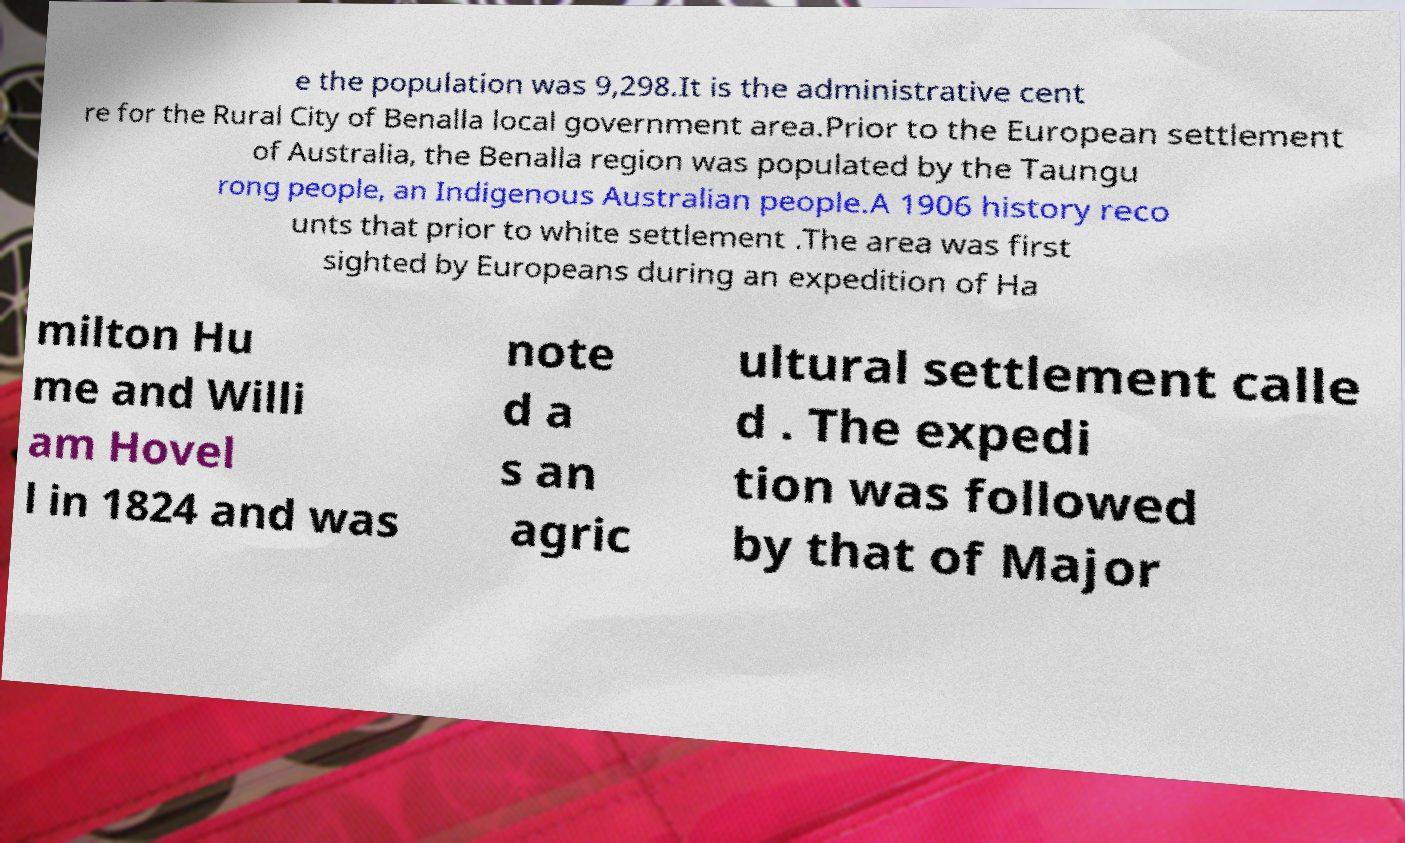Can you accurately transcribe the text from the provided image for me? e the population was 9,298.It is the administrative cent re for the Rural City of Benalla local government area.Prior to the European settlement of Australia, the Benalla region was populated by the Taungu rong people, an Indigenous Australian people.A 1906 history reco unts that prior to white settlement .The area was first sighted by Europeans during an expedition of Ha milton Hu me and Willi am Hovel l in 1824 and was note d a s an agric ultural settlement calle d . The expedi tion was followed by that of Major 